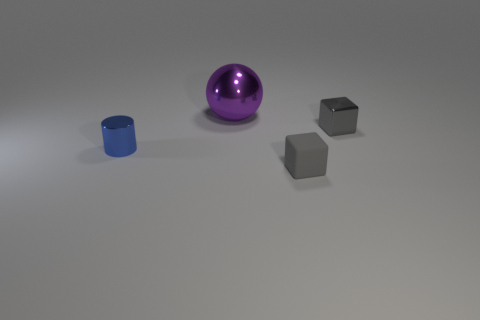Add 3 metallic cylinders. How many objects exist? 7 Subtract all cylinders. How many objects are left? 3 Subtract all large yellow balls. Subtract all small blue objects. How many objects are left? 3 Add 3 large metal things. How many large metal things are left? 4 Add 4 big gray metallic cylinders. How many big gray metallic cylinders exist? 4 Subtract 0 blue spheres. How many objects are left? 4 